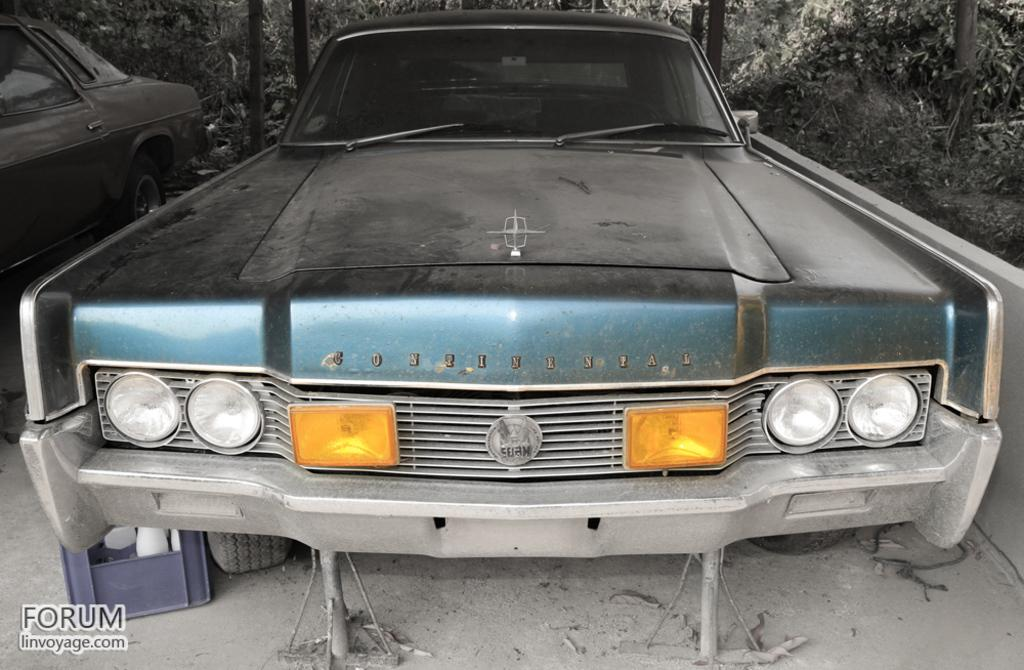How many cars can be seen in the image? There are two cars in the image. Where are the cars located? The cars are on the ground. What can be seen in the background of the image? There are trees visible in the background of the image. Where is the nest located in the image? There is no nest present in the image. What is the elbow used for in the image? There is no elbow present in the image. 